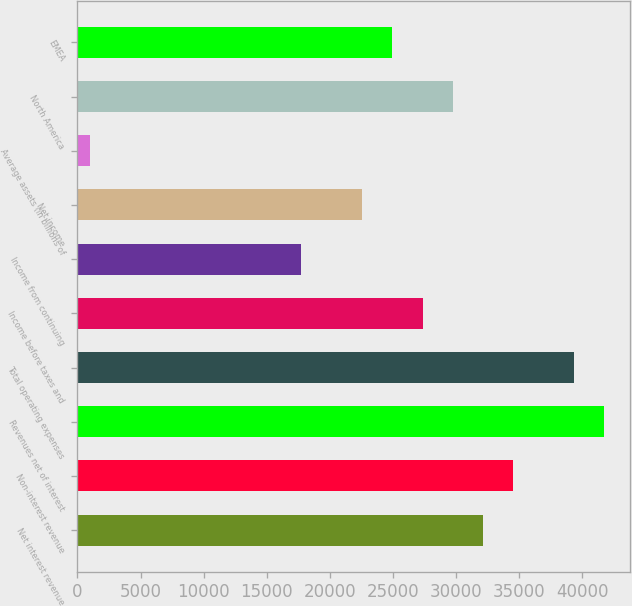<chart> <loc_0><loc_0><loc_500><loc_500><bar_chart><fcel>Net interest revenue<fcel>Non-interest revenue<fcel>Revenues net of interest<fcel>Total operating expenses<fcel>Income before taxes and<fcel>Income from continuing<fcel>Net income<fcel>Average assets (in billions of<fcel>North America<fcel>EMEA<nl><fcel>32125.7<fcel>34522.6<fcel>41713.3<fcel>39316.4<fcel>27331.9<fcel>17744.3<fcel>22538.1<fcel>966<fcel>29728.8<fcel>24935<nl></chart> 